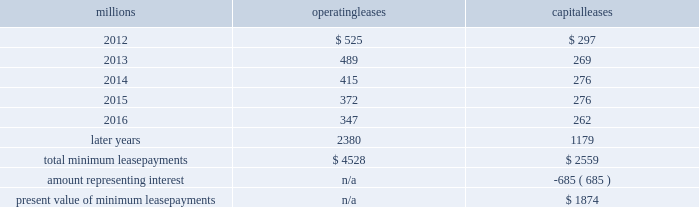The redemptions resulted in an early extinguishment charge of $ 5 million .
On march 22 , 2010 , we redeemed $ 175 million of our 6.5% ( 6.5 % ) notes due april 15 , 2012 .
The redemption resulted in an early extinguishment charge of $ 16 million in the first quarter of 2010 .
On november 1 , 2010 , we redeemed all $ 400 million of our outstanding 6.65% ( 6.65 % ) notes due january 15 , 2011 .
The redemption resulted in a $ 5 million early extinguishment charge .
Receivables securitization facility 2013 as of december 31 , 2011 and 2010 , we have recorded $ 100 million as secured debt under our receivables securitization facility .
( see further discussion of our receivables securitization facility in note 10 ) .
15 .
Variable interest entities we have entered into various lease transactions in which the structure of the leases contain variable interest entities ( vies ) .
These vies were created solely for the purpose of doing lease transactions ( principally involving railroad equipment and facilities , including our headquarters building ) and have no other activities , assets or liabilities outside of the lease transactions .
Within these lease arrangements , we have the right to purchase some or all of the assets at fixed prices .
Depending on market conditions , fixed-price purchase options available in the leases could potentially provide benefits to us ; however , these benefits are not expected to be significant .
We maintain and operate the assets based on contractual obligations within the lease arrangements , which set specific guidelines consistent within the railroad industry .
As such , we have no control over activities that could materially impact the fair value of the leased assets .
We do not hold the power to direct the activities of the vies and , therefore , do not control the ongoing activities that have a significant impact on the economic performance of the vies .
Additionally , we do not have the obligation to absorb losses of the vies or the right to receive benefits of the vies that could potentially be significant to the we are not considered to be the primary beneficiary and do not consolidate these vies because our actions and decisions do not have the most significant effect on the vie 2019s performance and our fixed-price purchase price options are not considered to be potentially significant to the vie 2019s .
The future minimum lease payments associated with the vie leases totaled $ 3.9 billion as of december 31 , 2011 .
16 .
Leases we lease certain locomotives , freight cars , and other property .
The consolidated statement of financial position as of december 31 , 2011 and 2010 included $ 2458 million , net of $ 915 million of accumulated depreciation , and $ 2520 million , net of $ 901 million of accumulated depreciation , respectively , for properties held under capital leases .
A charge to income resulting from the depreciation for assets held under capital leases is included within depreciation expense in our consolidated statements of income .
Future minimum lease payments for operating and capital leases with initial or remaining non-cancelable lease terms in excess of one year as of december 31 , 2011 , were as follows : millions operating leases capital leases .
The majority of capital lease payments relate to locomotives .
Rent expense for operating leases with terms exceeding one month was $ 637 million in 2011 , $ 624 million in 2010 , and $ 686 million in 2009 .
When cash rental payments are not made on a straight-line basis , we recognize variable rental expense on a straight-line basis over the lease term .
Contingent rentals and sub-rentals are not significant. .
Did the annual interest savings on the redemption of the 6.65% ( 6.65 % ) notes exceed the cost of the early extinguishment? 
Computations: ((400 * 6.65%) > 5)
Answer: yes. 